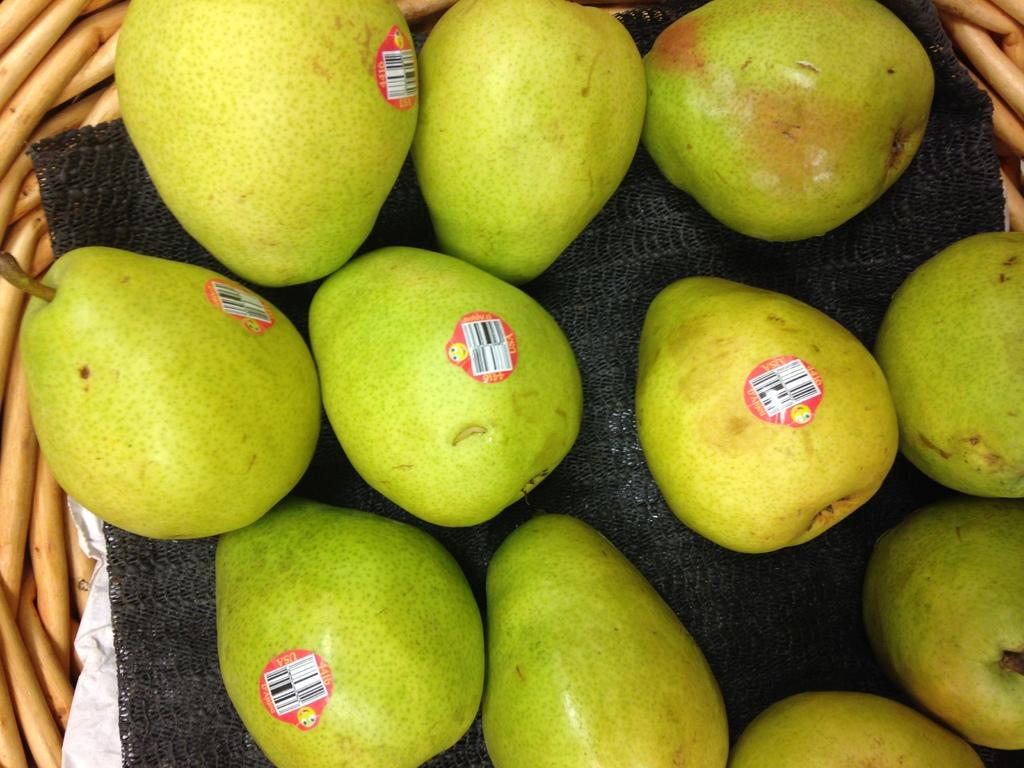What object is present in the image that can hold items? There is a basket in the image. What is inside the basket? The basket contains a cloth and a few beers. What type of work is being done by the people in the image? There are no people present in the image, so it is not possible to determine what type of work they might be doing. 